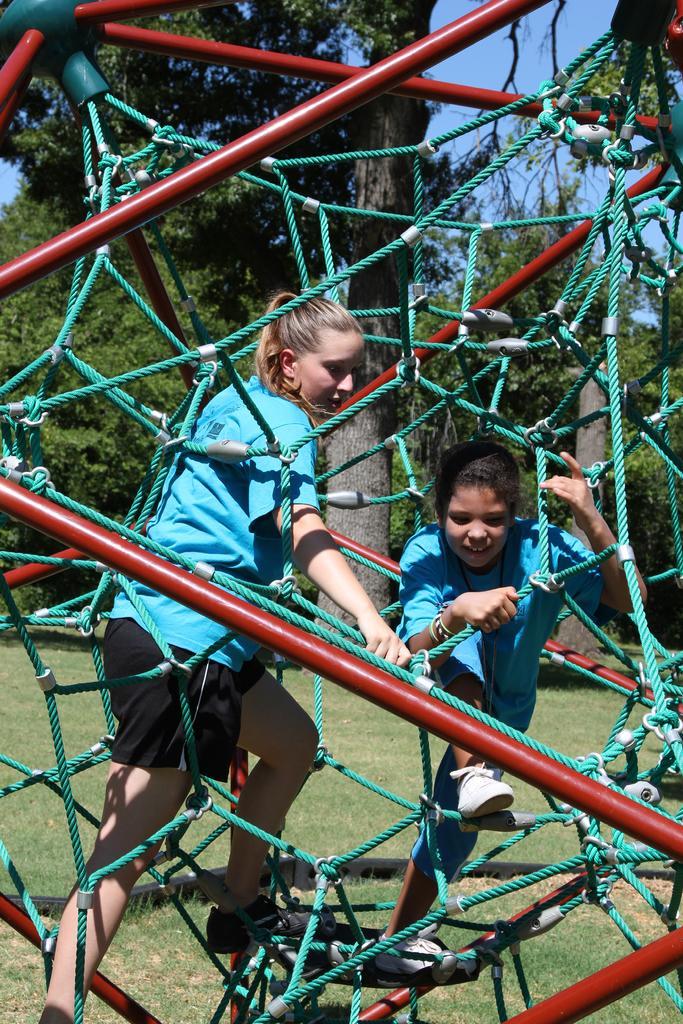How would you summarize this image in a sentence or two? In this image in the foreground there are two people who are playing something, and there is a net and some poles and in the background there are trees. At the bottom there is grass, and at the top there is sky. 